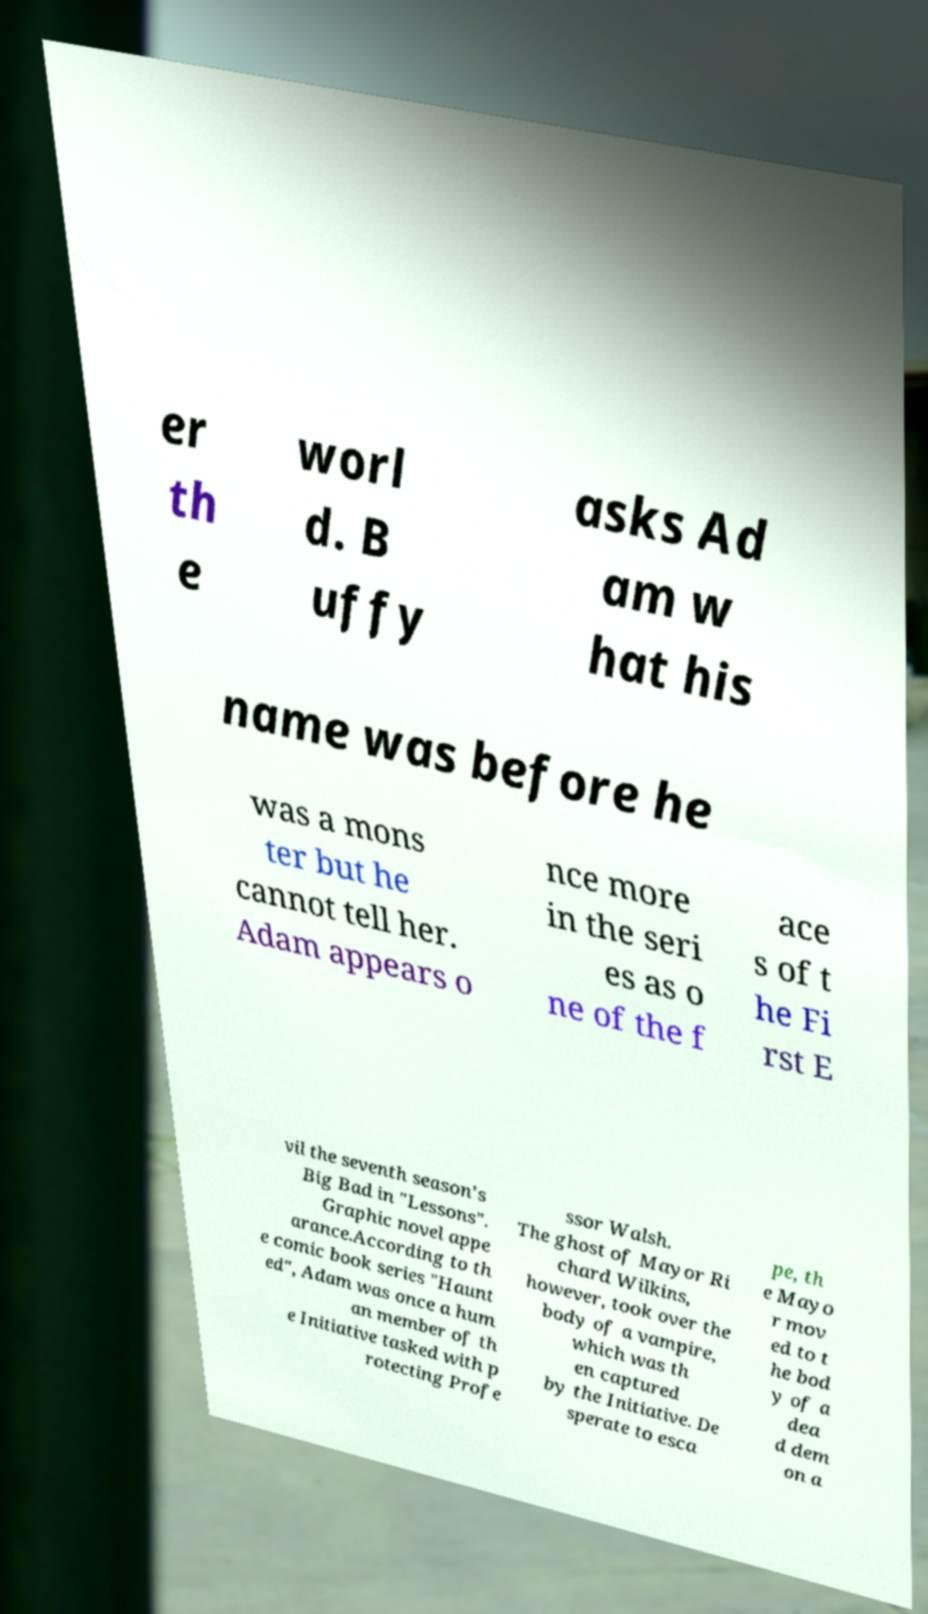Can you read and provide the text displayed in the image?This photo seems to have some interesting text. Can you extract and type it out for me? er th e worl d. B uffy asks Ad am w hat his name was before he was a mons ter but he cannot tell her. Adam appears o nce more in the seri es as o ne of the f ace s of t he Fi rst E vil the seventh season's Big Bad in "Lessons". Graphic novel appe arance.According to th e comic book series "Haunt ed", Adam was once a hum an member of th e Initiative tasked with p rotecting Profe ssor Walsh. The ghost of Mayor Ri chard Wilkins, however, took over the body of a vampire, which was th en captured by the Initiative. De sperate to esca pe, th e Mayo r mov ed to t he bod y of a dea d dem on a 